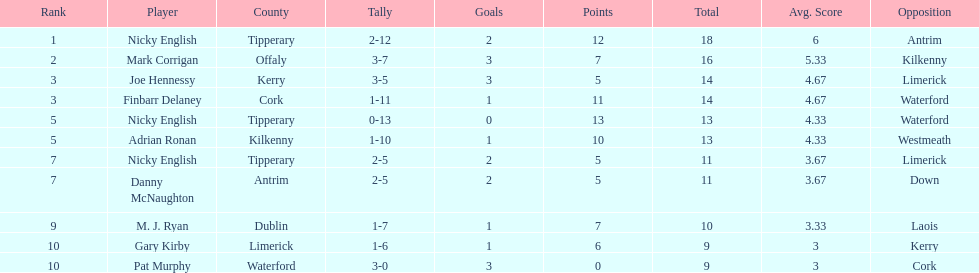Can you give me this table as a dict? {'header': ['Rank', 'Player', 'County', 'Tally', 'Goals', 'Points', 'Total', 'Avg. Score', 'Opposition'], 'rows': [['1', 'Nicky English', 'Tipperary', '2-12', '2', '12', '18', '6', 'Antrim'], ['2', 'Mark Corrigan', 'Offaly', '3-7', '3', '7', '16', '5.33', 'Kilkenny'], ['3', 'Joe Hennessy', 'Kerry', '3-5', '3', '5', '14', '4.67', 'Limerick'], ['3', 'Finbarr Delaney', 'Cork', '1-11', '1', '11', '14', '4.67', 'Waterford'], ['5', 'Nicky English', 'Tipperary', '0-13', '0', '13', '13', '4.33', 'Waterford'], ['5', 'Adrian Ronan', 'Kilkenny', '1-10', '1', '10', '13', '4.33', 'Westmeath'], ['7', 'Nicky English', 'Tipperary', '2-5', '2', '5', '11', '3.67', 'Limerick'], ['7', 'Danny McNaughton', 'Antrim', '2-5', '2', '5', '11', '3.67', 'Down'], ['9', 'M. J. Ryan', 'Dublin', '1-7', '1', '7', '10', '3.33', 'Laois'], ['10', 'Gary Kirby', 'Limerick', '1-6', '1', '6', '9', '3', 'Kerry'], ['10', 'Pat Murphy', 'Waterford', '3-0', '3', '0', '9', '3', 'Cork']]} If you added all the total's up, what would the number be? 138. 